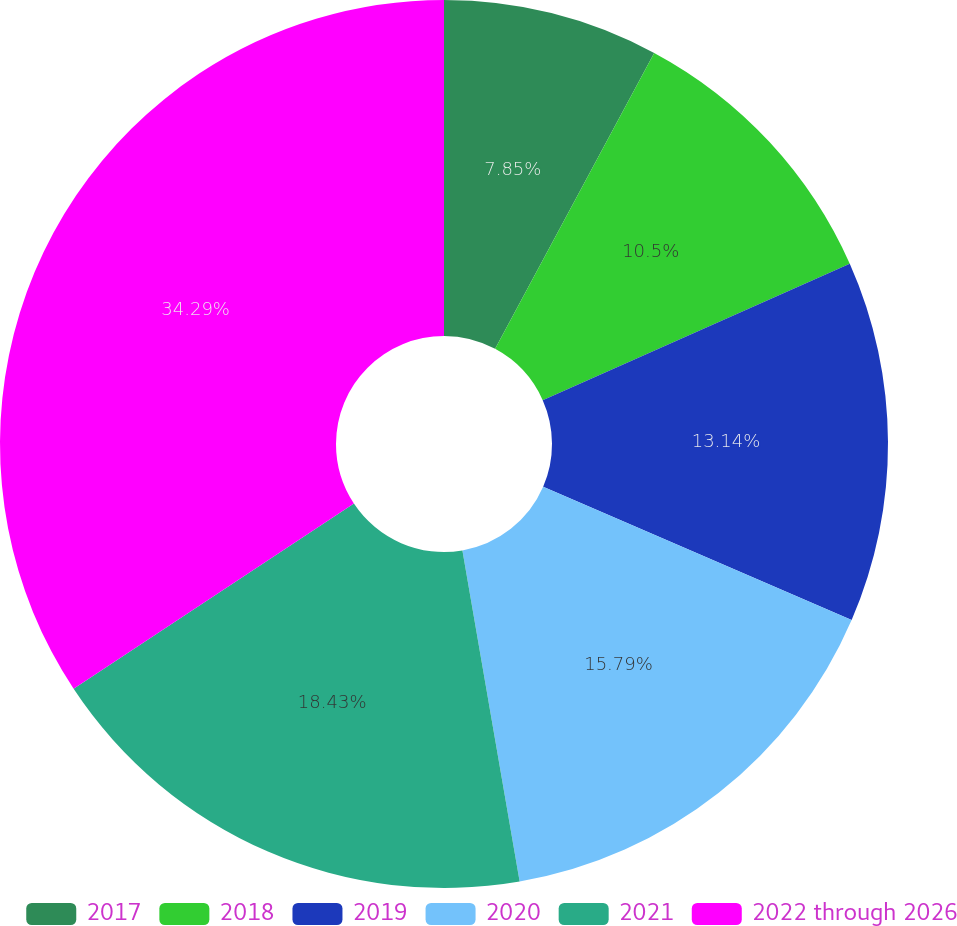<chart> <loc_0><loc_0><loc_500><loc_500><pie_chart><fcel>2017<fcel>2018<fcel>2019<fcel>2020<fcel>2021<fcel>2022 through 2026<nl><fcel>7.85%<fcel>10.5%<fcel>13.14%<fcel>15.79%<fcel>18.43%<fcel>34.3%<nl></chart> 